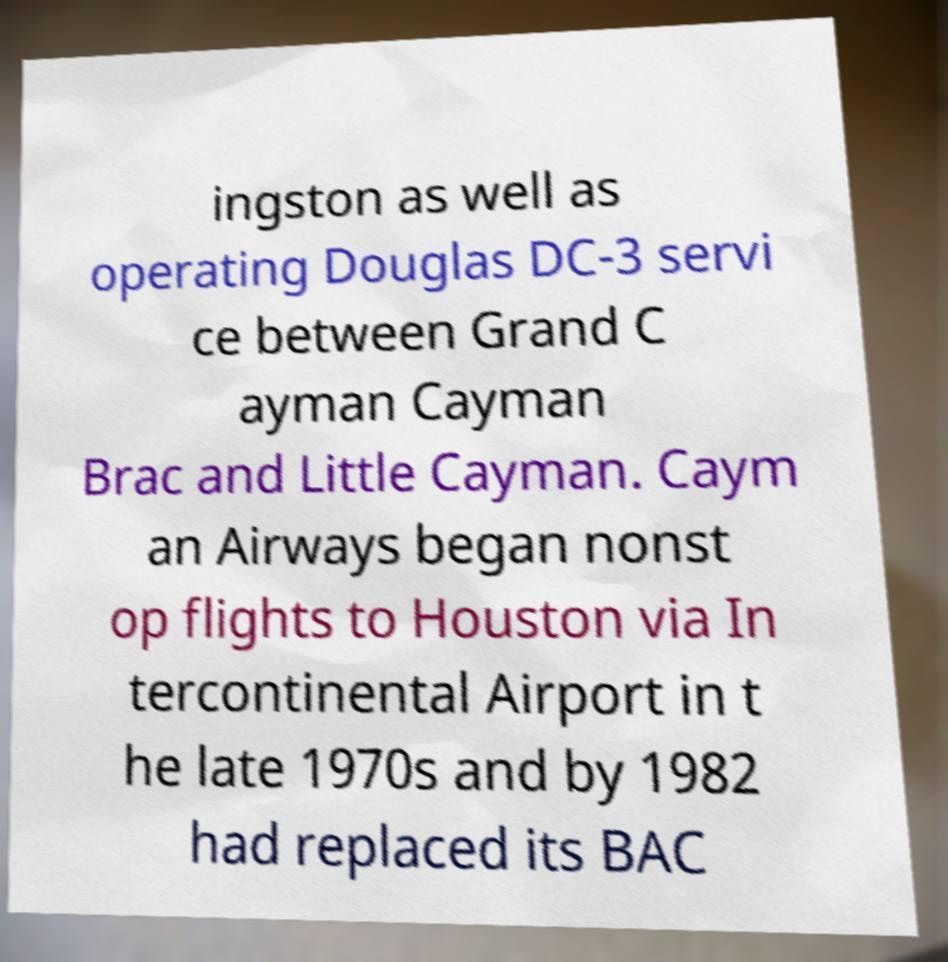For documentation purposes, I need the text within this image transcribed. Could you provide that? ingston as well as operating Douglas DC-3 servi ce between Grand C ayman Cayman Brac and Little Cayman. Caym an Airways began nonst op flights to Houston via In tercontinental Airport in t he late 1970s and by 1982 had replaced its BAC 